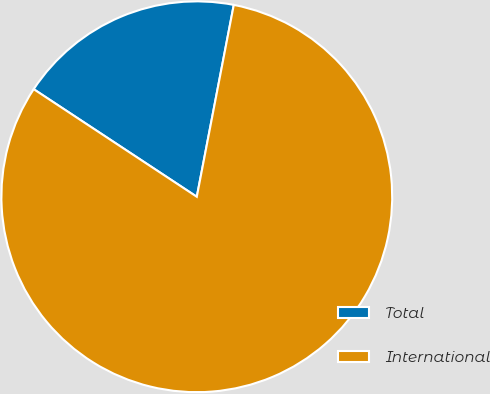<chart> <loc_0><loc_0><loc_500><loc_500><pie_chart><fcel>Total<fcel>International<nl><fcel>18.75%<fcel>81.25%<nl></chart> 